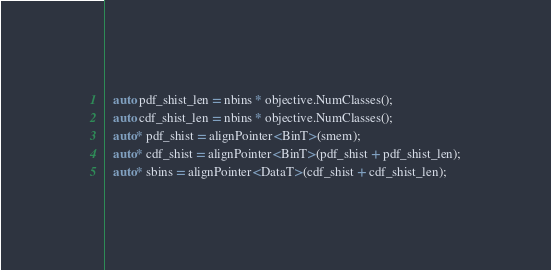<code> <loc_0><loc_0><loc_500><loc_500><_Cuda_>  auto pdf_shist_len = nbins * objective.NumClasses();
  auto cdf_shist_len = nbins * objective.NumClasses();
  auto* pdf_shist = alignPointer<BinT>(smem);
  auto* cdf_shist = alignPointer<BinT>(pdf_shist + pdf_shist_len);
  auto* sbins = alignPointer<DataT>(cdf_shist + cdf_shist_len);</code> 